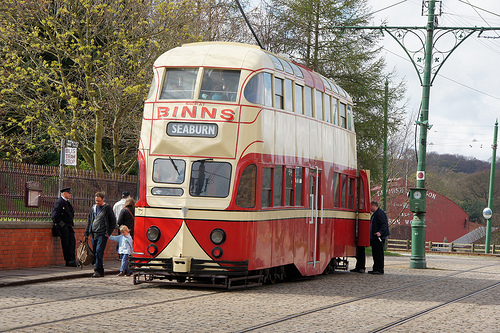<image>
Can you confirm if the man is behind the fence? No. The man is not behind the fence. From this viewpoint, the man appears to be positioned elsewhere in the scene. Where is the sign in relation to the kid? Is it above the kid? Yes. The sign is positioned above the kid in the vertical space, higher up in the scene. 